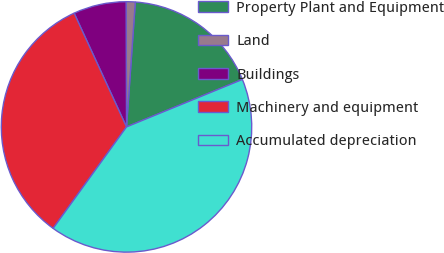<chart> <loc_0><loc_0><loc_500><loc_500><pie_chart><fcel>Property Plant and Equipment<fcel>Land<fcel>Buildings<fcel>Machinery and equipment<fcel>Accumulated depreciation<nl><fcel>17.69%<fcel>1.17%<fcel>6.82%<fcel>33.16%<fcel>41.15%<nl></chart> 